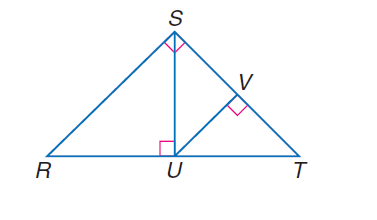Answer the mathemtical geometry problem and directly provide the correct option letter.
Question: If \angle R S T is a right angle, S U \perp R T, U V \perp S T, and m \angle R T S = 47, find m \angle R.
Choices: A: 25 B: 33 C: 40 D: 43 D 